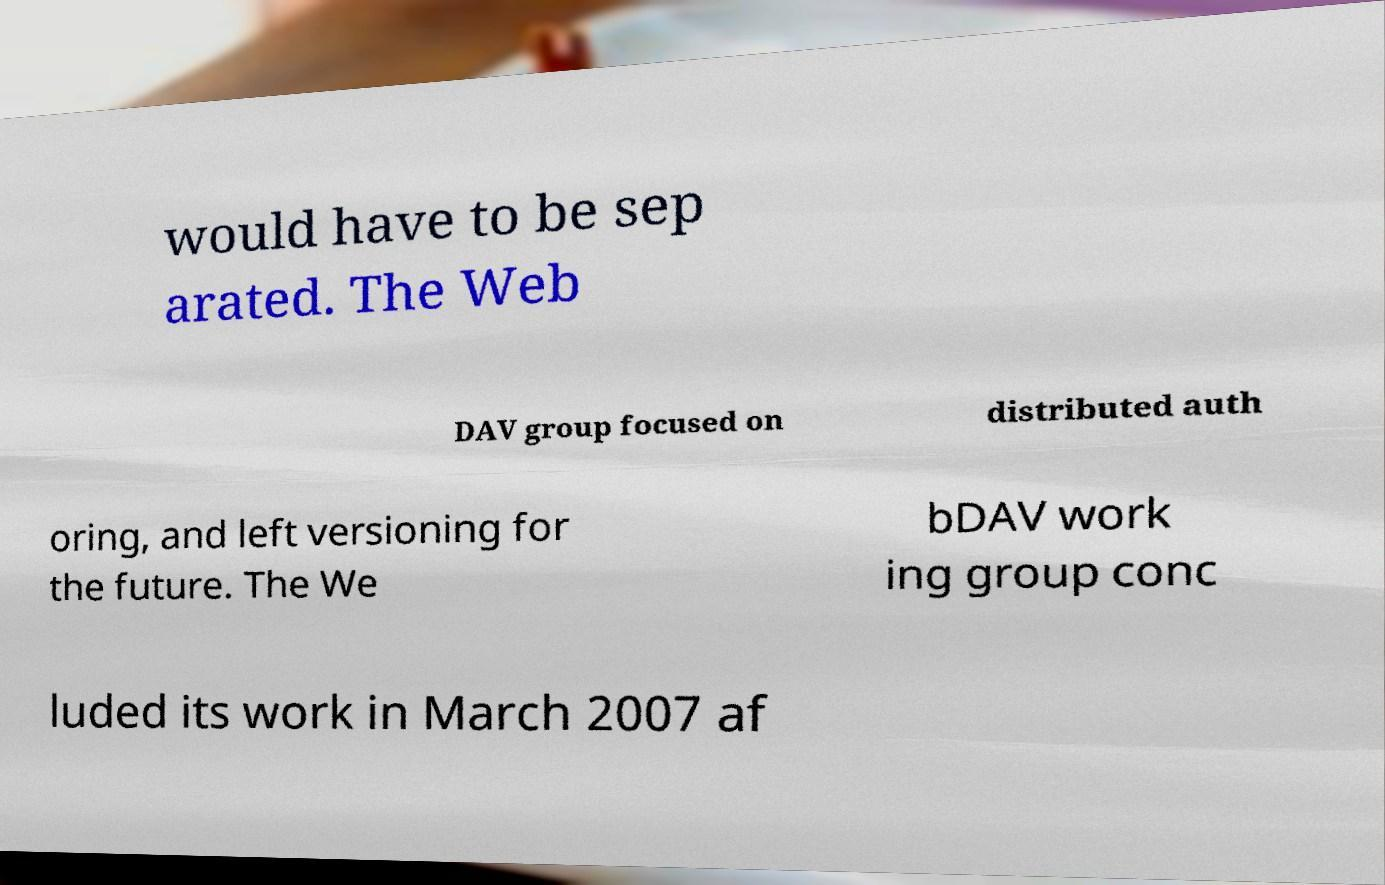Could you assist in decoding the text presented in this image and type it out clearly? would have to be sep arated. The Web DAV group focused on distributed auth oring, and left versioning for the future. The We bDAV work ing group conc luded its work in March 2007 af 